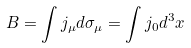Convert formula to latex. <formula><loc_0><loc_0><loc_500><loc_500>B = \int j _ { \mu } d \sigma _ { \mu } = \int j _ { 0 } d ^ { 3 } x</formula> 